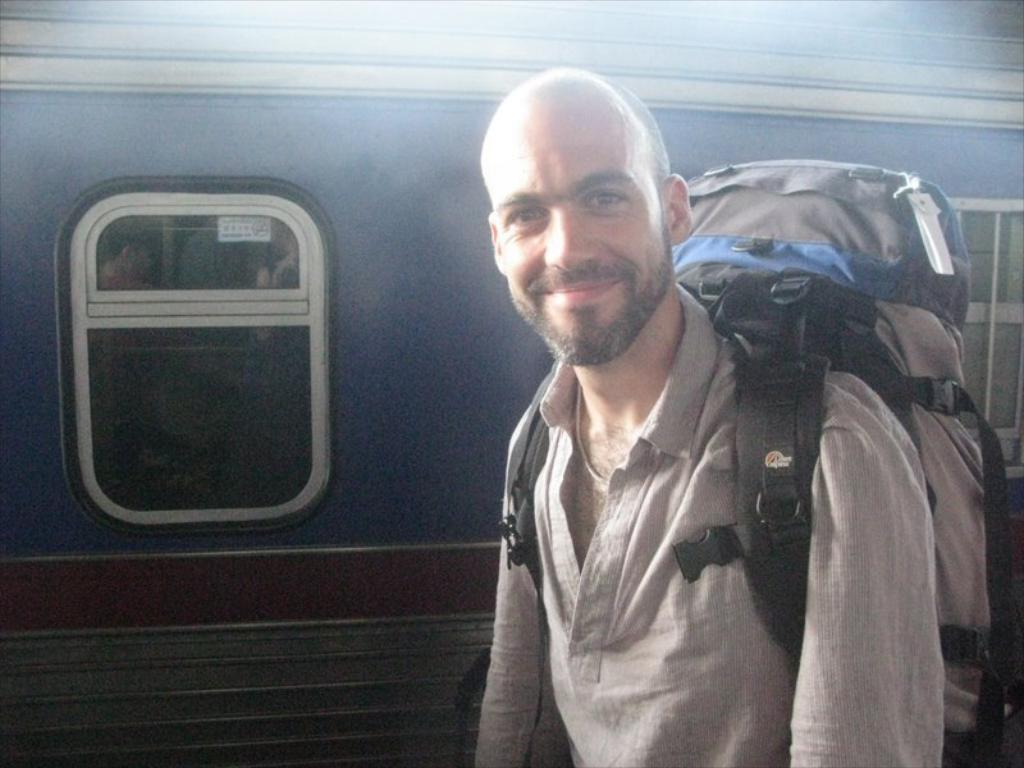Who is present in the image? There is a man in the image. What is the man doing in the image? The man is standing behind a train. What is the man wearing in the image? The man is wearing a backpack. What type of trousers is the man wearing in the advertisement? There is no advertisement present in the image, and no information is given about the man's trousers. 